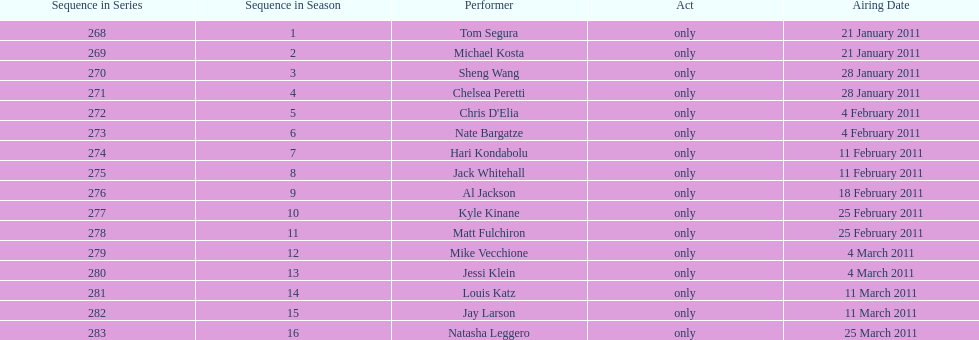Which month had the most performers? February. 